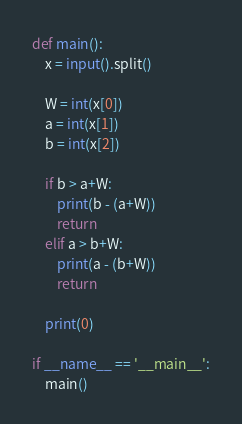<code> <loc_0><loc_0><loc_500><loc_500><_Python_>def main():
    x = input().split()

    W = int(x[0])
    a = int(x[1])
    b = int(x[2])

    if b > a+W:
        print(b - (a+W))
        return
    elif a > b+W:
        print(a - (b+W))
        return

    print(0)

if __name__ == '__main__':
    main()</code> 